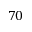<formula> <loc_0><loc_0><loc_500><loc_500>7 0</formula> 